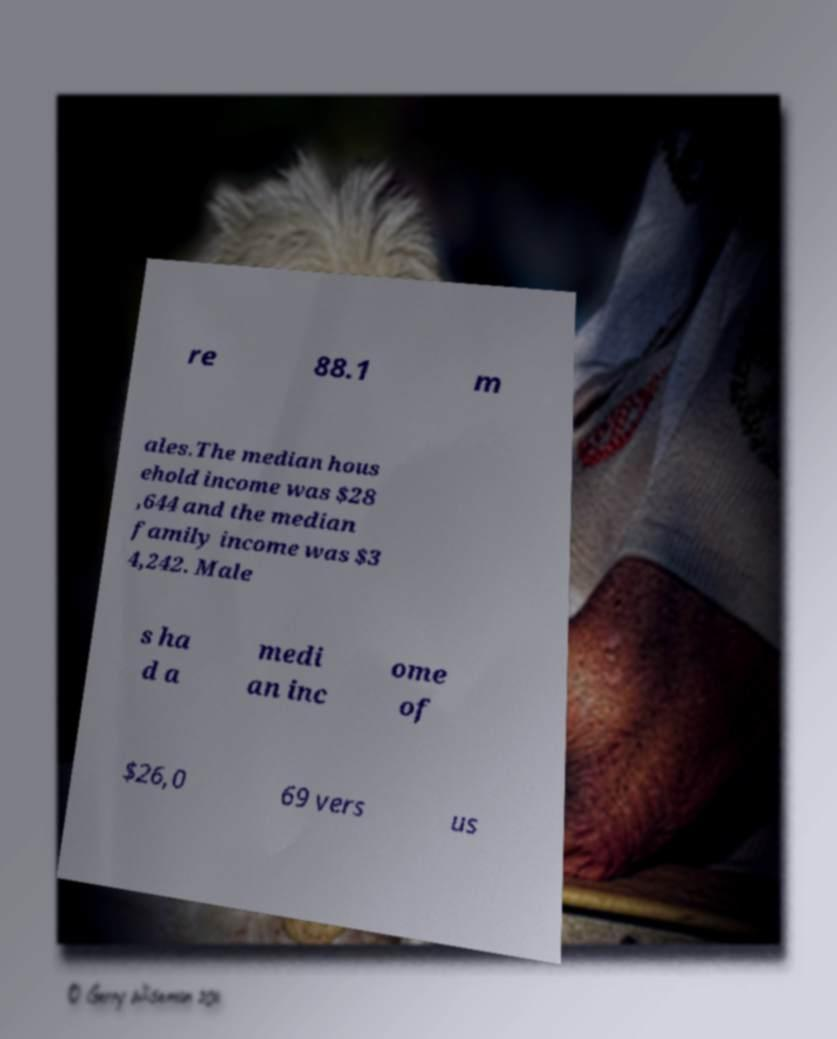There's text embedded in this image that I need extracted. Can you transcribe it verbatim? re 88.1 m ales.The median hous ehold income was $28 ,644 and the median family income was $3 4,242. Male s ha d a medi an inc ome of $26,0 69 vers us 